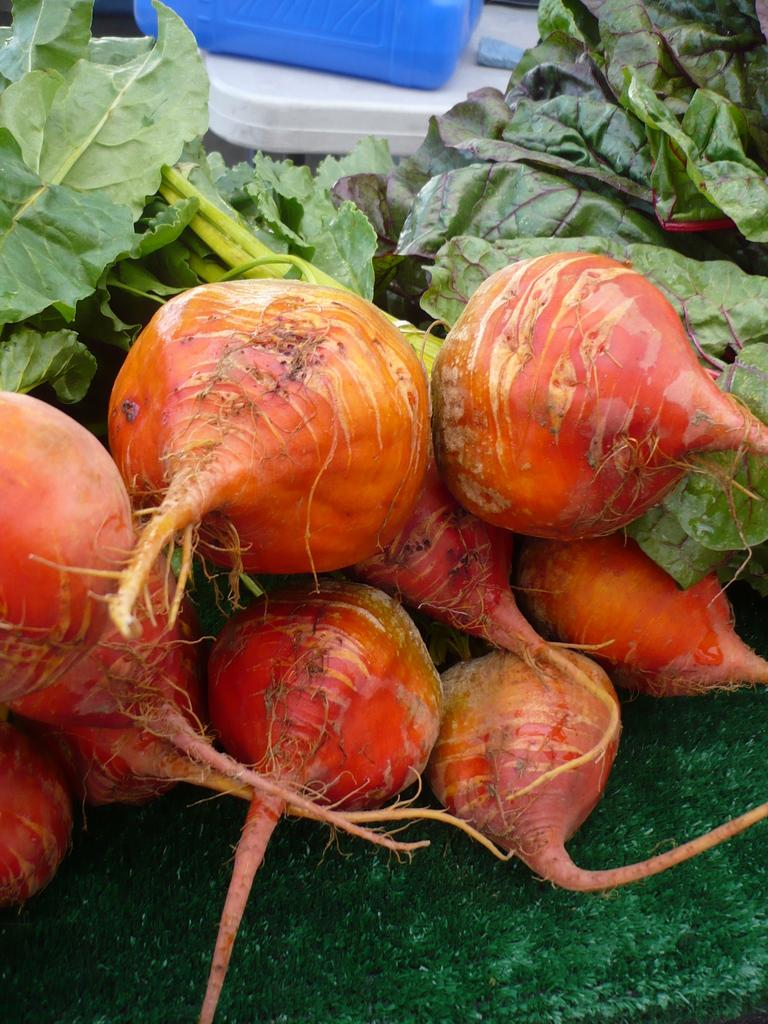What is the main subject in the foreground of the image? There are beetroots in the foreground of the image. What can be seen in the background of the image? There are objects in the background of the image. What type of society is depicted in the image? There is no society depicted in the image; it features beetroots in the foreground and objects in the background. How does the soap play a role in the image? There is no soap present in the image. 